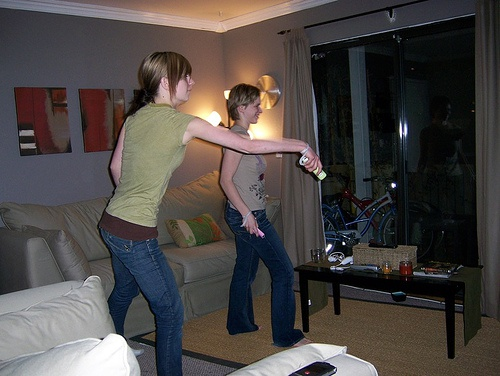Describe the objects in this image and their specific colors. I can see people in gray, black, and navy tones, couch in gray and black tones, couch in gray, darkgray, lightgray, and black tones, people in gray and black tones, and bicycle in gray, black, navy, and blue tones in this image. 